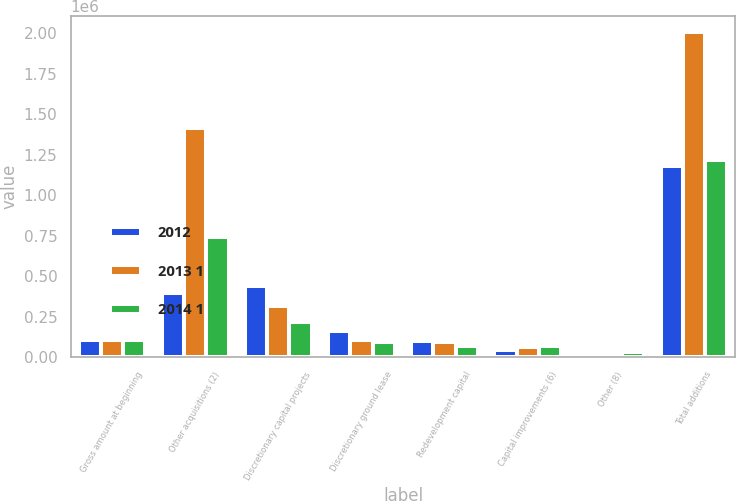<chart> <loc_0><loc_0><loc_500><loc_500><stacked_bar_chart><ecel><fcel>Gross amount at beginning<fcel>Other acquisitions (2)<fcel>Discretionary capital projects<fcel>Discretionary ground lease<fcel>Redevelopment capital<fcel>Capital improvements (6)<fcel>Other (8)<fcel>Total additions<nl><fcel>2012<fcel>102991<fcel>397837<fcel>437720<fcel>159637<fcel>96782<fcel>41967<fcel>22069<fcel>1.17718e+06<nl><fcel>2013 1<fcel>102991<fcel>1.41517e+06<fcel>314126<fcel>102991<fcel>89960<fcel>58960<fcel>8764<fcel>2.00573e+06<nl><fcel>2014 1<fcel>102991<fcel>739144<fcel>217935<fcel>93990<fcel>67309<fcel>70453<fcel>30813<fcel>1.21964e+06<nl></chart> 